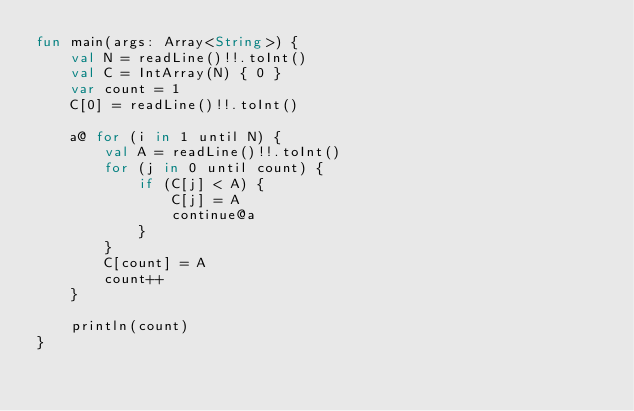<code> <loc_0><loc_0><loc_500><loc_500><_Kotlin_>fun main(args: Array<String>) {
    val N = readLine()!!.toInt()
    val C = IntArray(N) { 0 }
    var count = 1
    C[0] = readLine()!!.toInt()

    a@ for (i in 1 until N) {
        val A = readLine()!!.toInt()
        for (j in 0 until count) {
            if (C[j] < A) {
                C[j] = A
                continue@a
            }
        }
        C[count] = A
        count++
    }

    println(count)
}</code> 